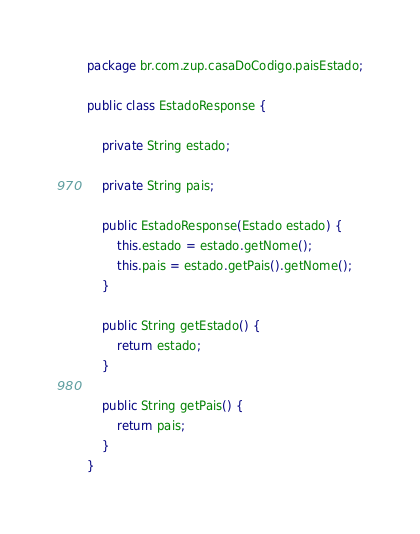Convert code to text. <code><loc_0><loc_0><loc_500><loc_500><_Java_>package br.com.zup.casaDoCodigo.paisEstado;

public class EstadoResponse {

    private String estado;

    private String pais;

    public EstadoResponse(Estado estado) {
        this.estado = estado.getNome();
        this.pais = estado.getPais().getNome();
    }

    public String getEstado() {
        return estado;
    }

    public String getPais() {
        return pais;
    }
}
</code> 